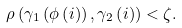<formula> <loc_0><loc_0><loc_500><loc_500>\rho \left ( \gamma _ { 1 } \left ( \phi \left ( i \right ) \right ) , \gamma _ { 2 } \left ( i \right ) \right ) < \zeta .</formula> 